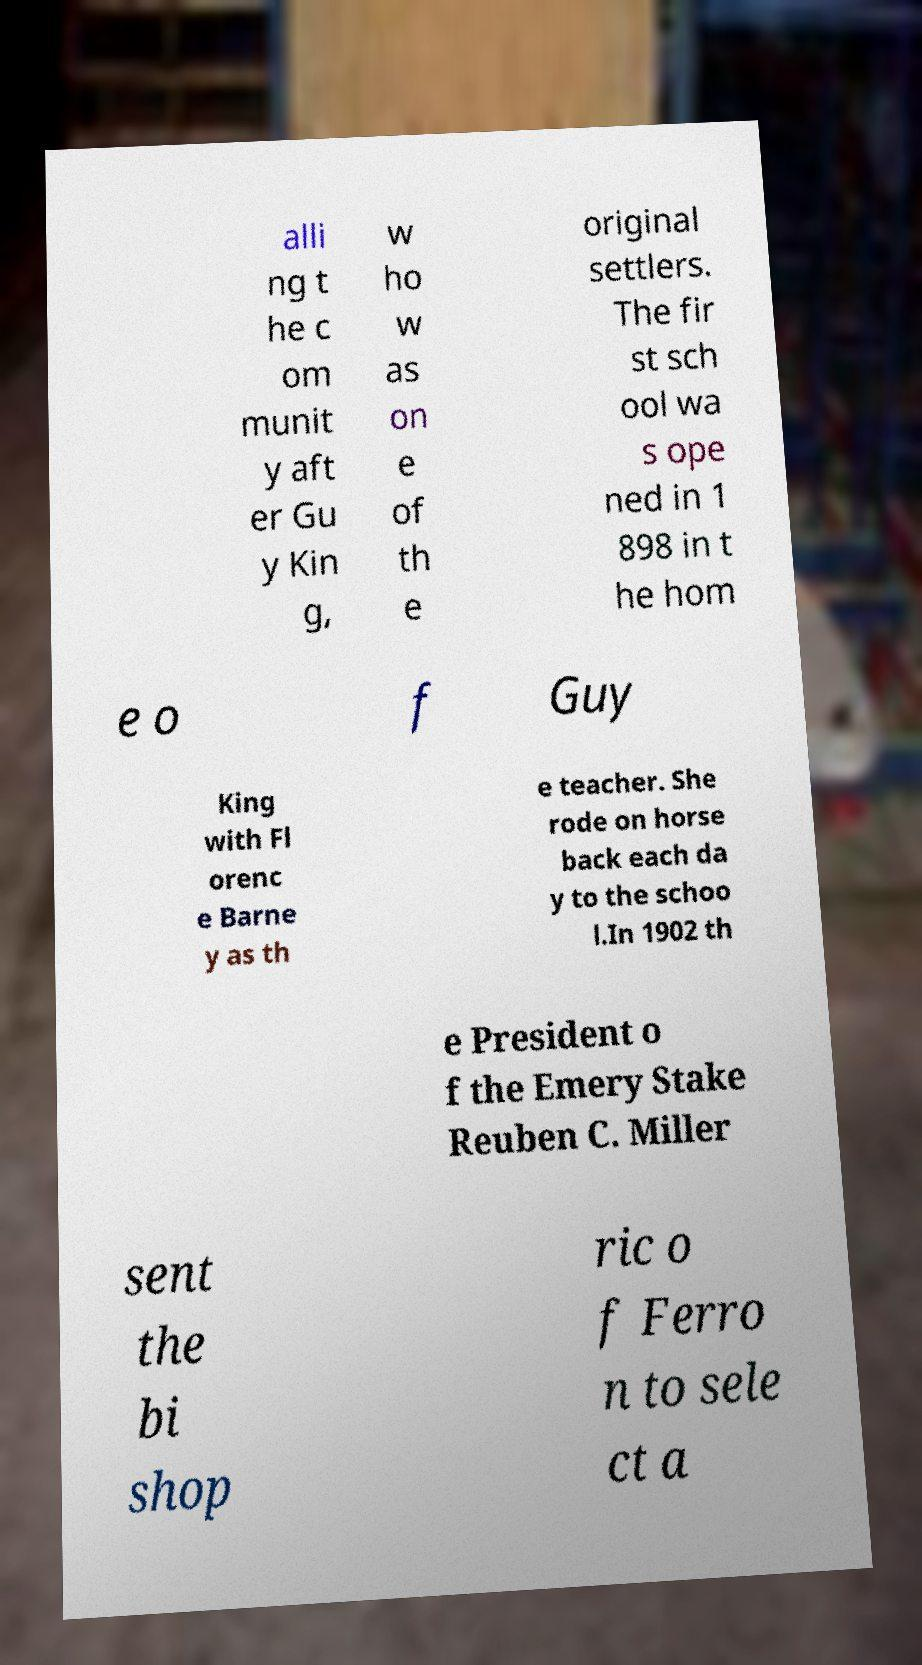There's text embedded in this image that I need extracted. Can you transcribe it verbatim? alli ng t he c om munit y aft er Gu y Kin g, w ho w as on e of th e original settlers. The fir st sch ool wa s ope ned in 1 898 in t he hom e o f Guy King with Fl orenc e Barne y as th e teacher. She rode on horse back each da y to the schoo l.In 1902 th e President o f the Emery Stake Reuben C. Miller sent the bi shop ric o f Ferro n to sele ct a 